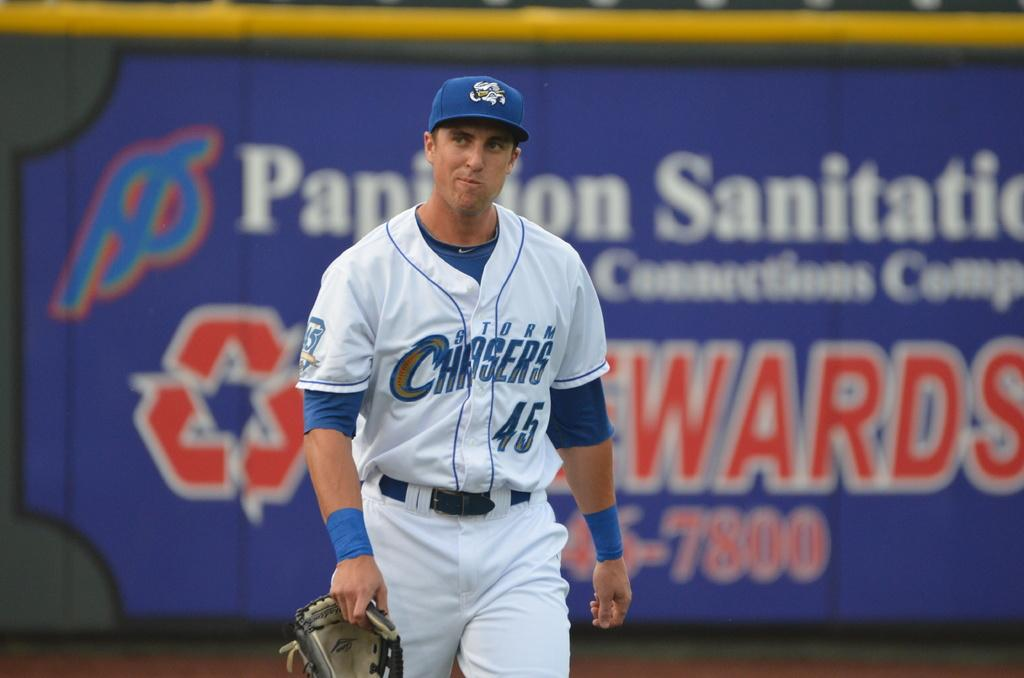Provide a one-sentence caption for the provided image. A baseball player in a Storm Chasers shirts holding a mitt. 